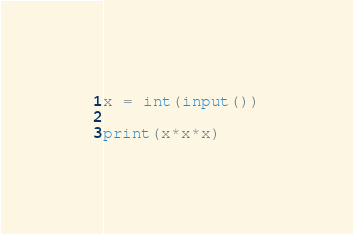<code> <loc_0><loc_0><loc_500><loc_500><_Python_>x = int(input())

print(x*x*x)
</code> 